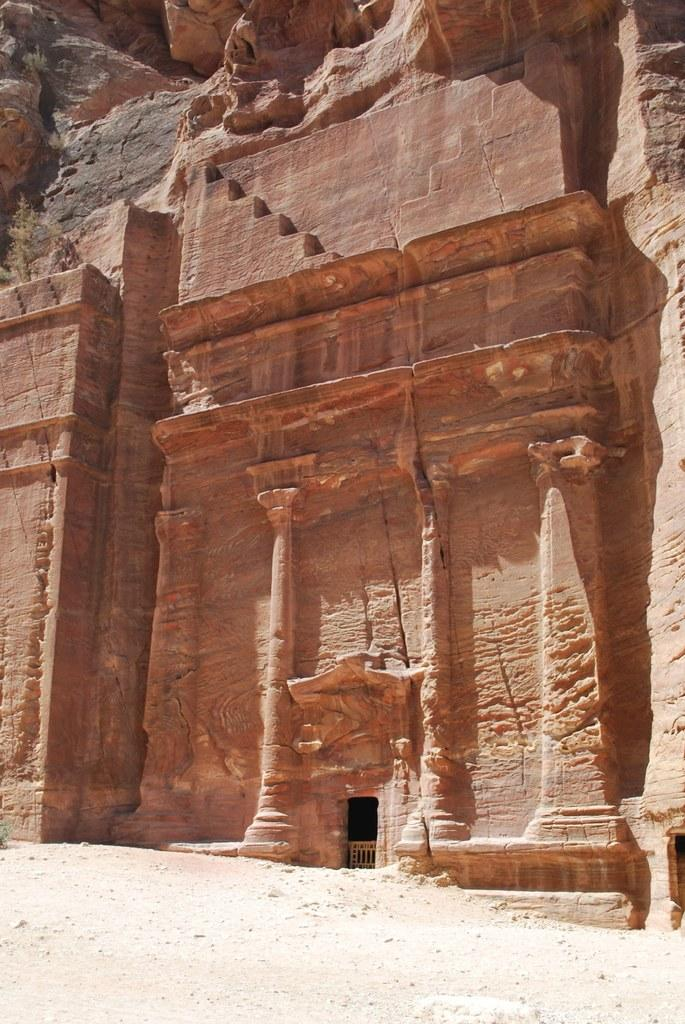What type of structure is depicted in the image? There is an ancient building in the image. What type of cough medicine is being used by the person in the image? There is no person present in the image, and therefore no cough medicine can be observed. What musical instrument is being played by the person in the image? There is no person present in the image, and therefore no musical instrument can be observed. 